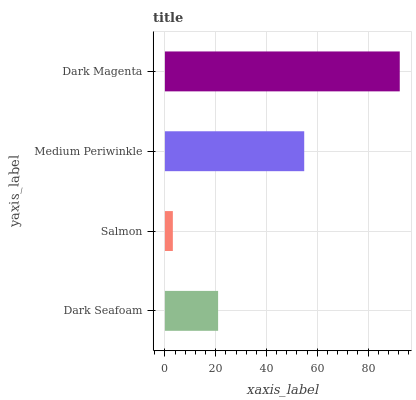Is Salmon the minimum?
Answer yes or no. Yes. Is Dark Magenta the maximum?
Answer yes or no. Yes. Is Medium Periwinkle the minimum?
Answer yes or no. No. Is Medium Periwinkle the maximum?
Answer yes or no. No. Is Medium Periwinkle greater than Salmon?
Answer yes or no. Yes. Is Salmon less than Medium Periwinkle?
Answer yes or no. Yes. Is Salmon greater than Medium Periwinkle?
Answer yes or no. No. Is Medium Periwinkle less than Salmon?
Answer yes or no. No. Is Medium Periwinkle the high median?
Answer yes or no. Yes. Is Dark Seafoam the low median?
Answer yes or no. Yes. Is Salmon the high median?
Answer yes or no. No. Is Salmon the low median?
Answer yes or no. No. 